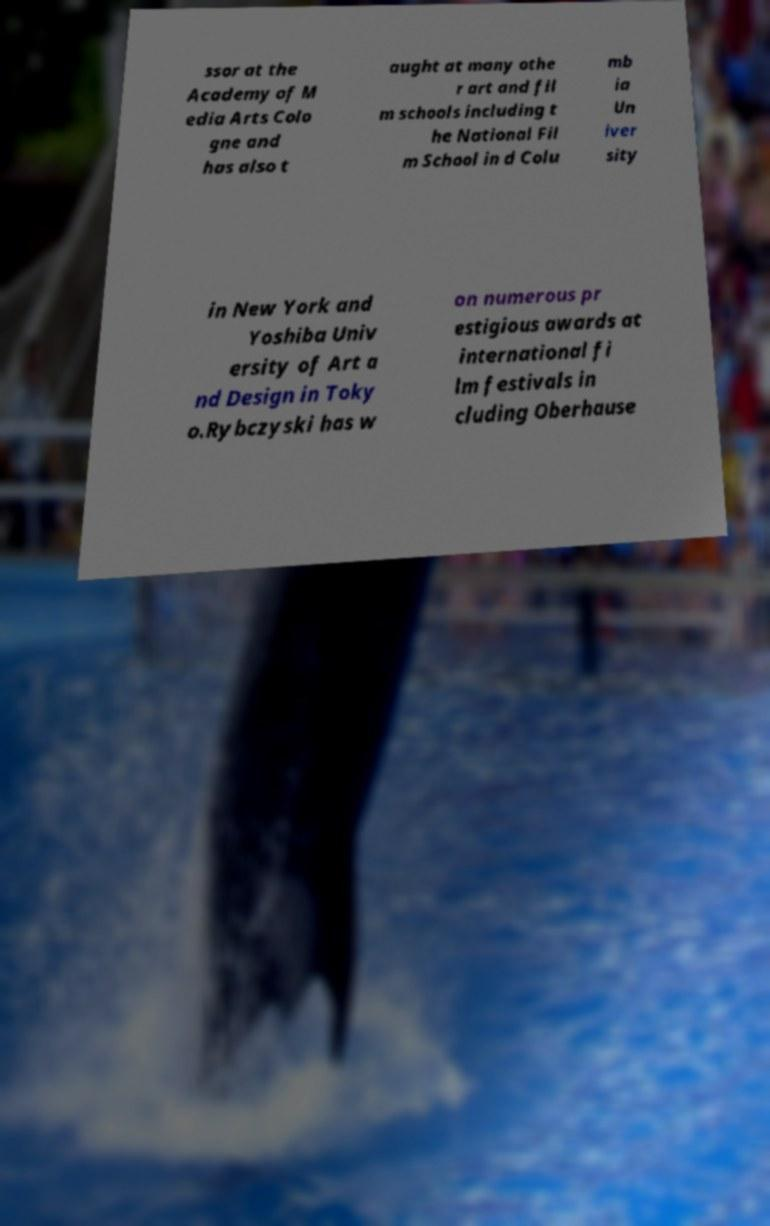Could you extract and type out the text from this image? ssor at the Academy of M edia Arts Colo gne and has also t aught at many othe r art and fil m schools including t he National Fil m School in d Colu mb ia Un iver sity in New York and Yoshiba Univ ersity of Art a nd Design in Toky o.Rybczyski has w on numerous pr estigious awards at international fi lm festivals in cluding Oberhause 